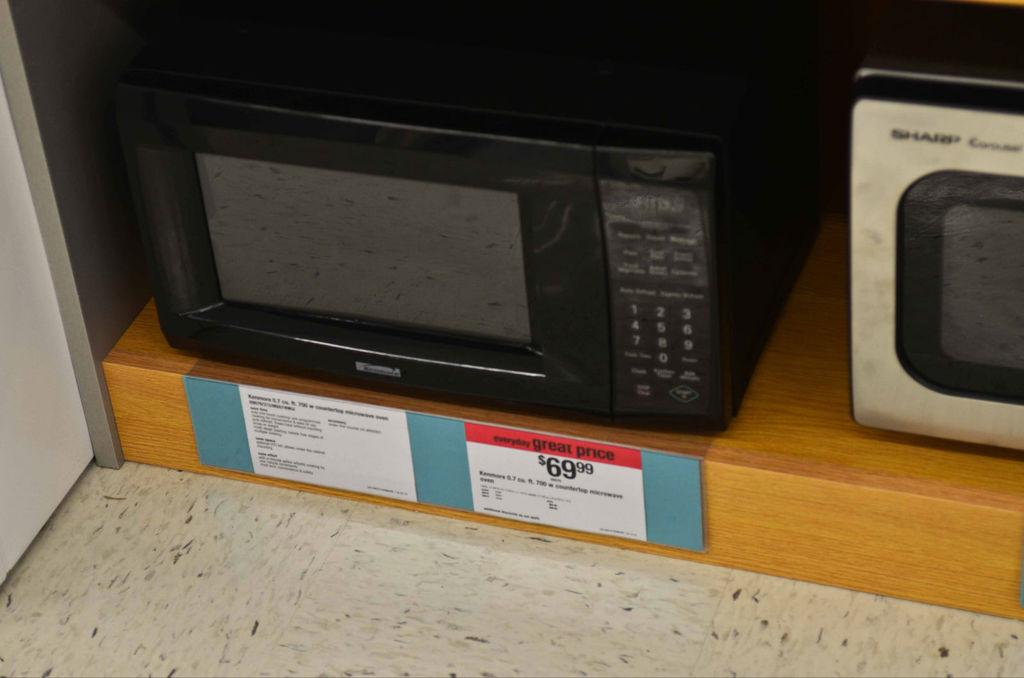<image>
Create a compact narrative representing the image presented. A microwave is displayed with a sale price of 69.99 dollars. 